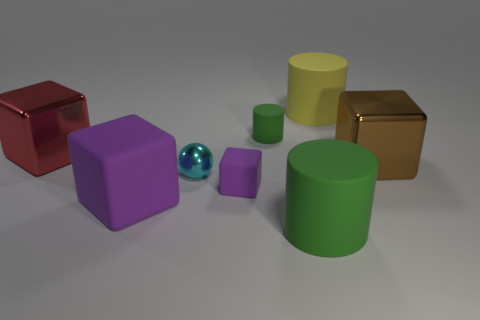Does the small matte cube have the same color as the large matte thing on the left side of the small cylinder?
Offer a terse response. Yes. How many things are either green rubber cylinders in front of the small cyan metallic ball or cylinders in front of the tiny purple block?
Your answer should be compact. 1. How many other objects are the same color as the small cylinder?
Provide a succinct answer. 1. Does the large yellow matte object have the same shape as the green thing that is behind the big brown metal cube?
Make the answer very short. Yes. Is the number of large red shiny objects that are in front of the small green cylinder less than the number of big cubes that are to the right of the small cyan metallic thing?
Your response must be concise. No. There is a tiny thing that is the same shape as the large brown thing; what is it made of?
Your answer should be compact. Rubber. Is the large matte block the same color as the tiny cube?
Your response must be concise. Yes. What is the shape of the yellow thing that is made of the same material as the tiny purple block?
Your answer should be very brief. Cylinder. What number of tiny cyan metal objects have the same shape as the large green thing?
Keep it short and to the point. 0. The green matte thing behind the green cylinder that is in front of the small cyan sphere is what shape?
Offer a terse response. Cylinder. 